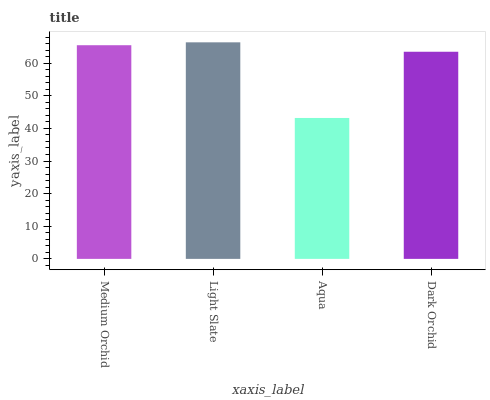Is Aqua the minimum?
Answer yes or no. Yes. Is Light Slate the maximum?
Answer yes or no. Yes. Is Light Slate the minimum?
Answer yes or no. No. Is Aqua the maximum?
Answer yes or no. No. Is Light Slate greater than Aqua?
Answer yes or no. Yes. Is Aqua less than Light Slate?
Answer yes or no. Yes. Is Aqua greater than Light Slate?
Answer yes or no. No. Is Light Slate less than Aqua?
Answer yes or no. No. Is Medium Orchid the high median?
Answer yes or no. Yes. Is Dark Orchid the low median?
Answer yes or no. Yes. Is Aqua the high median?
Answer yes or no. No. Is Aqua the low median?
Answer yes or no. No. 